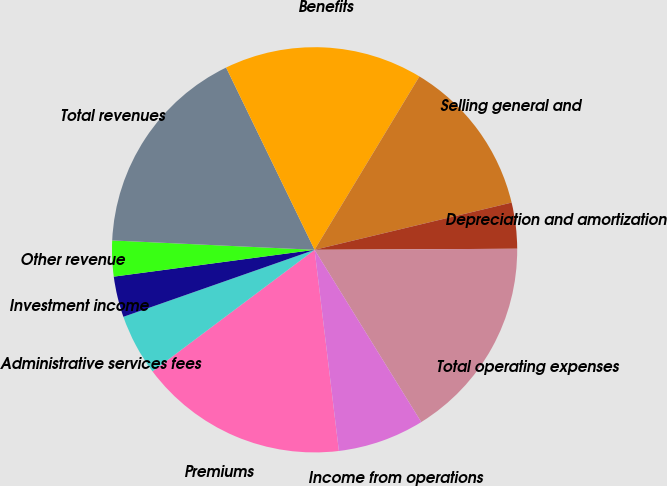Convert chart. <chart><loc_0><loc_0><loc_500><loc_500><pie_chart><fcel>Premiums<fcel>Administrative services fees<fcel>Investment income<fcel>Other revenue<fcel>Total revenues<fcel>Benefits<fcel>Selling general and<fcel>Depreciation and amortization<fcel>Total operating expenses<fcel>Income from operations<nl><fcel>16.67%<fcel>4.88%<fcel>3.25%<fcel>2.85%<fcel>17.07%<fcel>15.85%<fcel>12.6%<fcel>3.66%<fcel>16.26%<fcel>6.91%<nl></chart> 